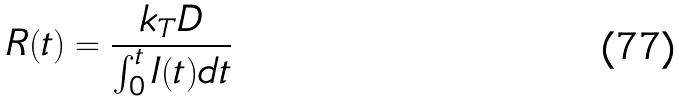<formula> <loc_0><loc_0><loc_500><loc_500>R ( t ) = \frac { k _ { T } D } { \int _ { 0 } ^ { t } I ( t ) d t }</formula> 